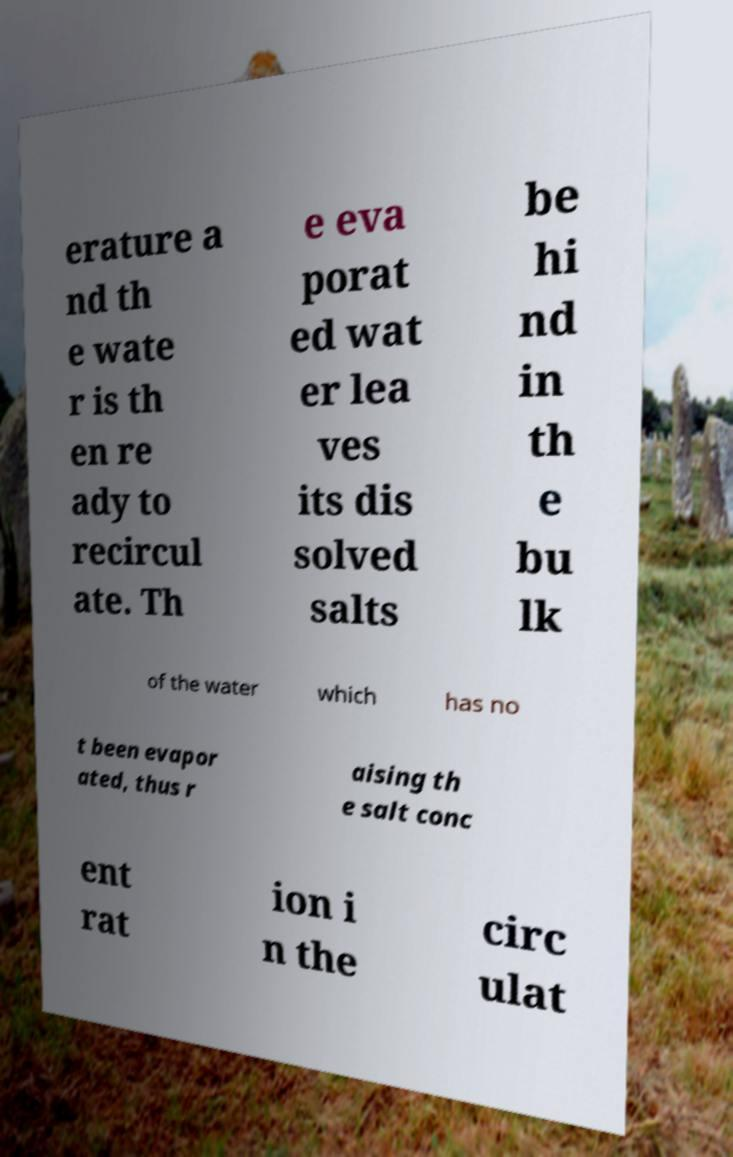I need the written content from this picture converted into text. Can you do that? erature a nd th e wate r is th en re ady to recircul ate. Th e eva porat ed wat er lea ves its dis solved salts be hi nd in th e bu lk of the water which has no t been evapor ated, thus r aising th e salt conc ent rat ion i n the circ ulat 